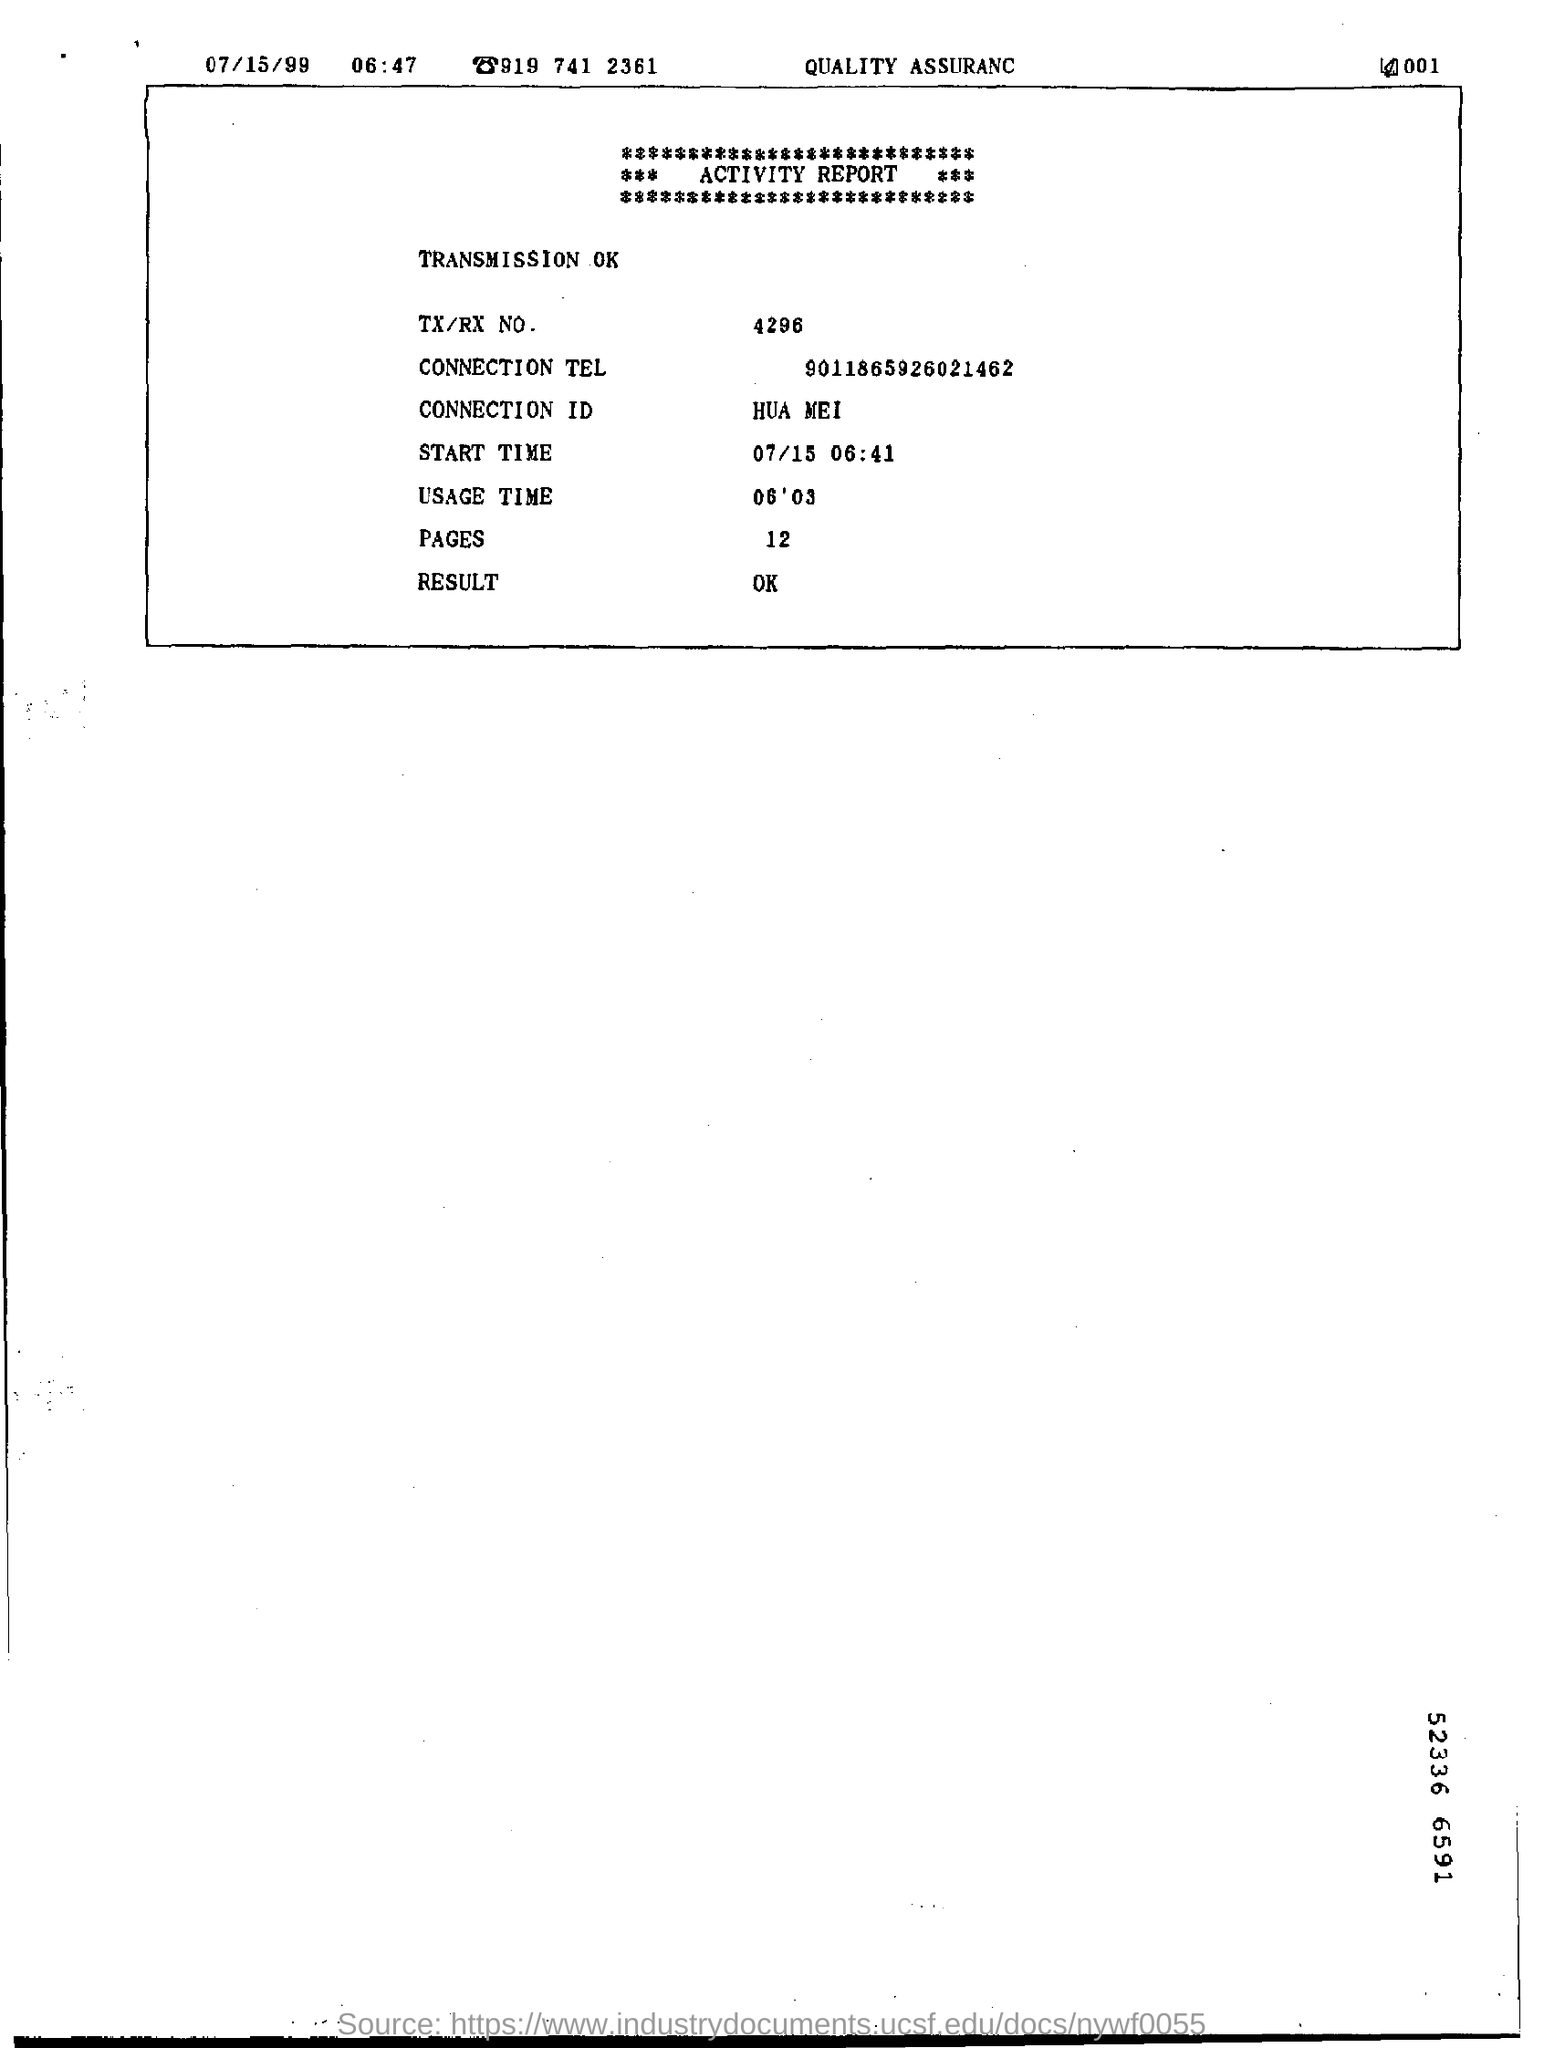Give some essential details in this illustration. The connection ID is unknown. 